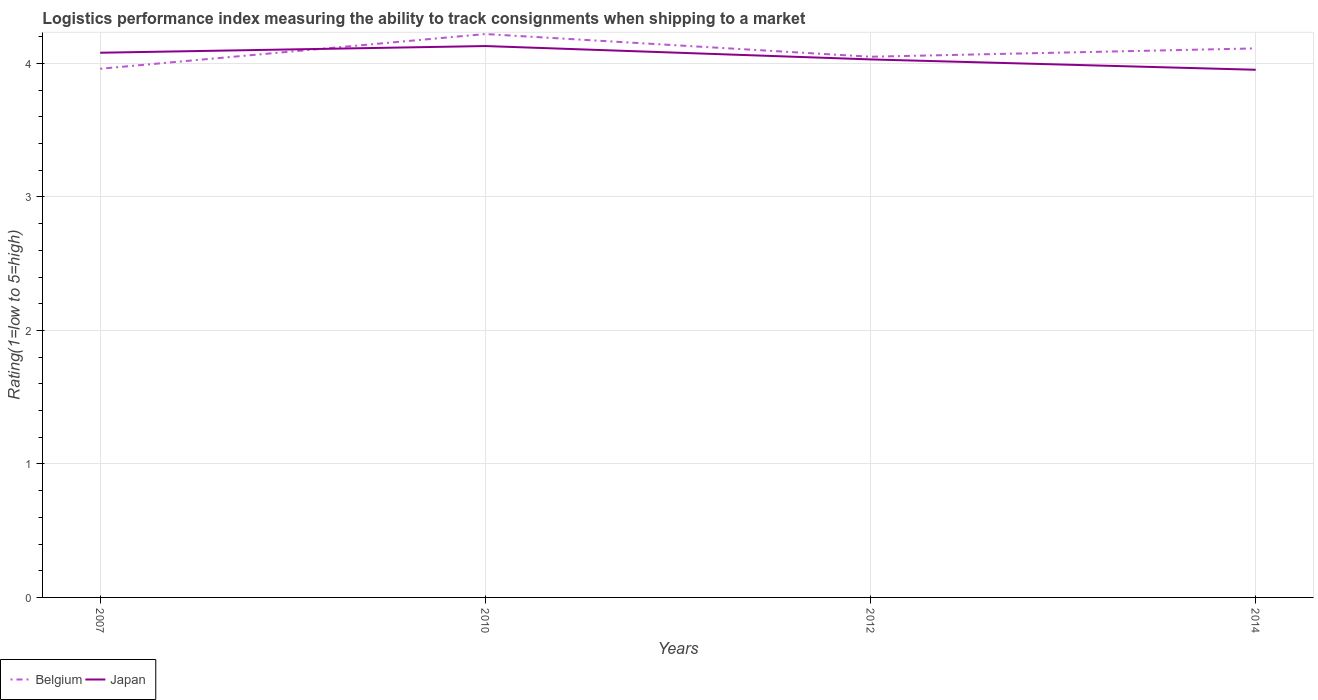How many different coloured lines are there?
Keep it short and to the point. 2. Is the number of lines equal to the number of legend labels?
Your answer should be very brief. Yes. Across all years, what is the maximum Logistic performance index in Japan?
Your response must be concise. 3.95. In which year was the Logistic performance index in Japan maximum?
Keep it short and to the point. 2014. What is the total Logistic performance index in Belgium in the graph?
Offer a terse response. -0.06. What is the difference between the highest and the second highest Logistic performance index in Belgium?
Your answer should be compact. 0.26. How many lines are there?
Your answer should be very brief. 2. How many years are there in the graph?
Provide a short and direct response. 4. What is the difference between two consecutive major ticks on the Y-axis?
Ensure brevity in your answer.  1. Are the values on the major ticks of Y-axis written in scientific E-notation?
Keep it short and to the point. No. Does the graph contain any zero values?
Your answer should be very brief. No. What is the title of the graph?
Offer a terse response. Logistics performance index measuring the ability to track consignments when shipping to a market. What is the label or title of the X-axis?
Provide a short and direct response. Years. What is the label or title of the Y-axis?
Your answer should be compact. Rating(1=low to 5=high). What is the Rating(1=low to 5=high) in Belgium in 2007?
Make the answer very short. 3.96. What is the Rating(1=low to 5=high) of Japan in 2007?
Provide a succinct answer. 4.08. What is the Rating(1=low to 5=high) of Belgium in 2010?
Offer a very short reply. 4.22. What is the Rating(1=low to 5=high) in Japan in 2010?
Offer a very short reply. 4.13. What is the Rating(1=low to 5=high) of Belgium in 2012?
Keep it short and to the point. 4.05. What is the Rating(1=low to 5=high) of Japan in 2012?
Your answer should be very brief. 4.03. What is the Rating(1=low to 5=high) of Belgium in 2014?
Offer a terse response. 4.11. What is the Rating(1=low to 5=high) of Japan in 2014?
Give a very brief answer. 3.95. Across all years, what is the maximum Rating(1=low to 5=high) of Belgium?
Your answer should be very brief. 4.22. Across all years, what is the maximum Rating(1=low to 5=high) in Japan?
Offer a very short reply. 4.13. Across all years, what is the minimum Rating(1=low to 5=high) of Belgium?
Make the answer very short. 3.96. Across all years, what is the minimum Rating(1=low to 5=high) of Japan?
Your answer should be compact. 3.95. What is the total Rating(1=low to 5=high) of Belgium in the graph?
Your answer should be compact. 16.34. What is the total Rating(1=low to 5=high) of Japan in the graph?
Your answer should be very brief. 16.19. What is the difference between the Rating(1=low to 5=high) of Belgium in 2007 and that in 2010?
Provide a short and direct response. -0.26. What is the difference between the Rating(1=low to 5=high) in Belgium in 2007 and that in 2012?
Give a very brief answer. -0.09. What is the difference between the Rating(1=low to 5=high) of Japan in 2007 and that in 2012?
Your answer should be very brief. 0.05. What is the difference between the Rating(1=low to 5=high) of Belgium in 2007 and that in 2014?
Offer a terse response. -0.15. What is the difference between the Rating(1=low to 5=high) of Japan in 2007 and that in 2014?
Provide a succinct answer. 0.13. What is the difference between the Rating(1=low to 5=high) of Belgium in 2010 and that in 2012?
Your response must be concise. 0.17. What is the difference between the Rating(1=low to 5=high) in Belgium in 2010 and that in 2014?
Provide a succinct answer. 0.11. What is the difference between the Rating(1=low to 5=high) in Japan in 2010 and that in 2014?
Ensure brevity in your answer.  0.18. What is the difference between the Rating(1=low to 5=high) of Belgium in 2012 and that in 2014?
Ensure brevity in your answer.  -0.06. What is the difference between the Rating(1=low to 5=high) of Japan in 2012 and that in 2014?
Provide a short and direct response. 0.08. What is the difference between the Rating(1=low to 5=high) of Belgium in 2007 and the Rating(1=low to 5=high) of Japan in 2010?
Keep it short and to the point. -0.17. What is the difference between the Rating(1=low to 5=high) of Belgium in 2007 and the Rating(1=low to 5=high) of Japan in 2012?
Give a very brief answer. -0.07. What is the difference between the Rating(1=low to 5=high) of Belgium in 2007 and the Rating(1=low to 5=high) of Japan in 2014?
Your answer should be compact. 0.01. What is the difference between the Rating(1=low to 5=high) of Belgium in 2010 and the Rating(1=low to 5=high) of Japan in 2012?
Provide a short and direct response. 0.19. What is the difference between the Rating(1=low to 5=high) in Belgium in 2010 and the Rating(1=low to 5=high) in Japan in 2014?
Keep it short and to the point. 0.27. What is the difference between the Rating(1=low to 5=high) of Belgium in 2012 and the Rating(1=low to 5=high) of Japan in 2014?
Ensure brevity in your answer.  0.1. What is the average Rating(1=low to 5=high) of Belgium per year?
Offer a very short reply. 4.09. What is the average Rating(1=low to 5=high) of Japan per year?
Make the answer very short. 4.05. In the year 2007, what is the difference between the Rating(1=low to 5=high) of Belgium and Rating(1=low to 5=high) of Japan?
Your answer should be very brief. -0.12. In the year 2010, what is the difference between the Rating(1=low to 5=high) of Belgium and Rating(1=low to 5=high) of Japan?
Give a very brief answer. 0.09. In the year 2014, what is the difference between the Rating(1=low to 5=high) in Belgium and Rating(1=low to 5=high) in Japan?
Make the answer very short. 0.16. What is the ratio of the Rating(1=low to 5=high) in Belgium in 2007 to that in 2010?
Keep it short and to the point. 0.94. What is the ratio of the Rating(1=low to 5=high) in Japan in 2007 to that in 2010?
Keep it short and to the point. 0.99. What is the ratio of the Rating(1=low to 5=high) of Belgium in 2007 to that in 2012?
Offer a very short reply. 0.98. What is the ratio of the Rating(1=low to 5=high) in Japan in 2007 to that in 2012?
Give a very brief answer. 1.01. What is the ratio of the Rating(1=low to 5=high) of Belgium in 2007 to that in 2014?
Make the answer very short. 0.96. What is the ratio of the Rating(1=low to 5=high) of Japan in 2007 to that in 2014?
Give a very brief answer. 1.03. What is the ratio of the Rating(1=low to 5=high) in Belgium in 2010 to that in 2012?
Ensure brevity in your answer.  1.04. What is the ratio of the Rating(1=low to 5=high) of Japan in 2010 to that in 2012?
Offer a very short reply. 1.02. What is the ratio of the Rating(1=low to 5=high) in Belgium in 2010 to that in 2014?
Make the answer very short. 1.03. What is the ratio of the Rating(1=low to 5=high) of Japan in 2010 to that in 2014?
Your response must be concise. 1.04. What is the ratio of the Rating(1=low to 5=high) in Japan in 2012 to that in 2014?
Offer a terse response. 1.02. What is the difference between the highest and the second highest Rating(1=low to 5=high) of Belgium?
Ensure brevity in your answer.  0.11. What is the difference between the highest and the lowest Rating(1=low to 5=high) in Belgium?
Keep it short and to the point. 0.26. What is the difference between the highest and the lowest Rating(1=low to 5=high) in Japan?
Offer a terse response. 0.18. 